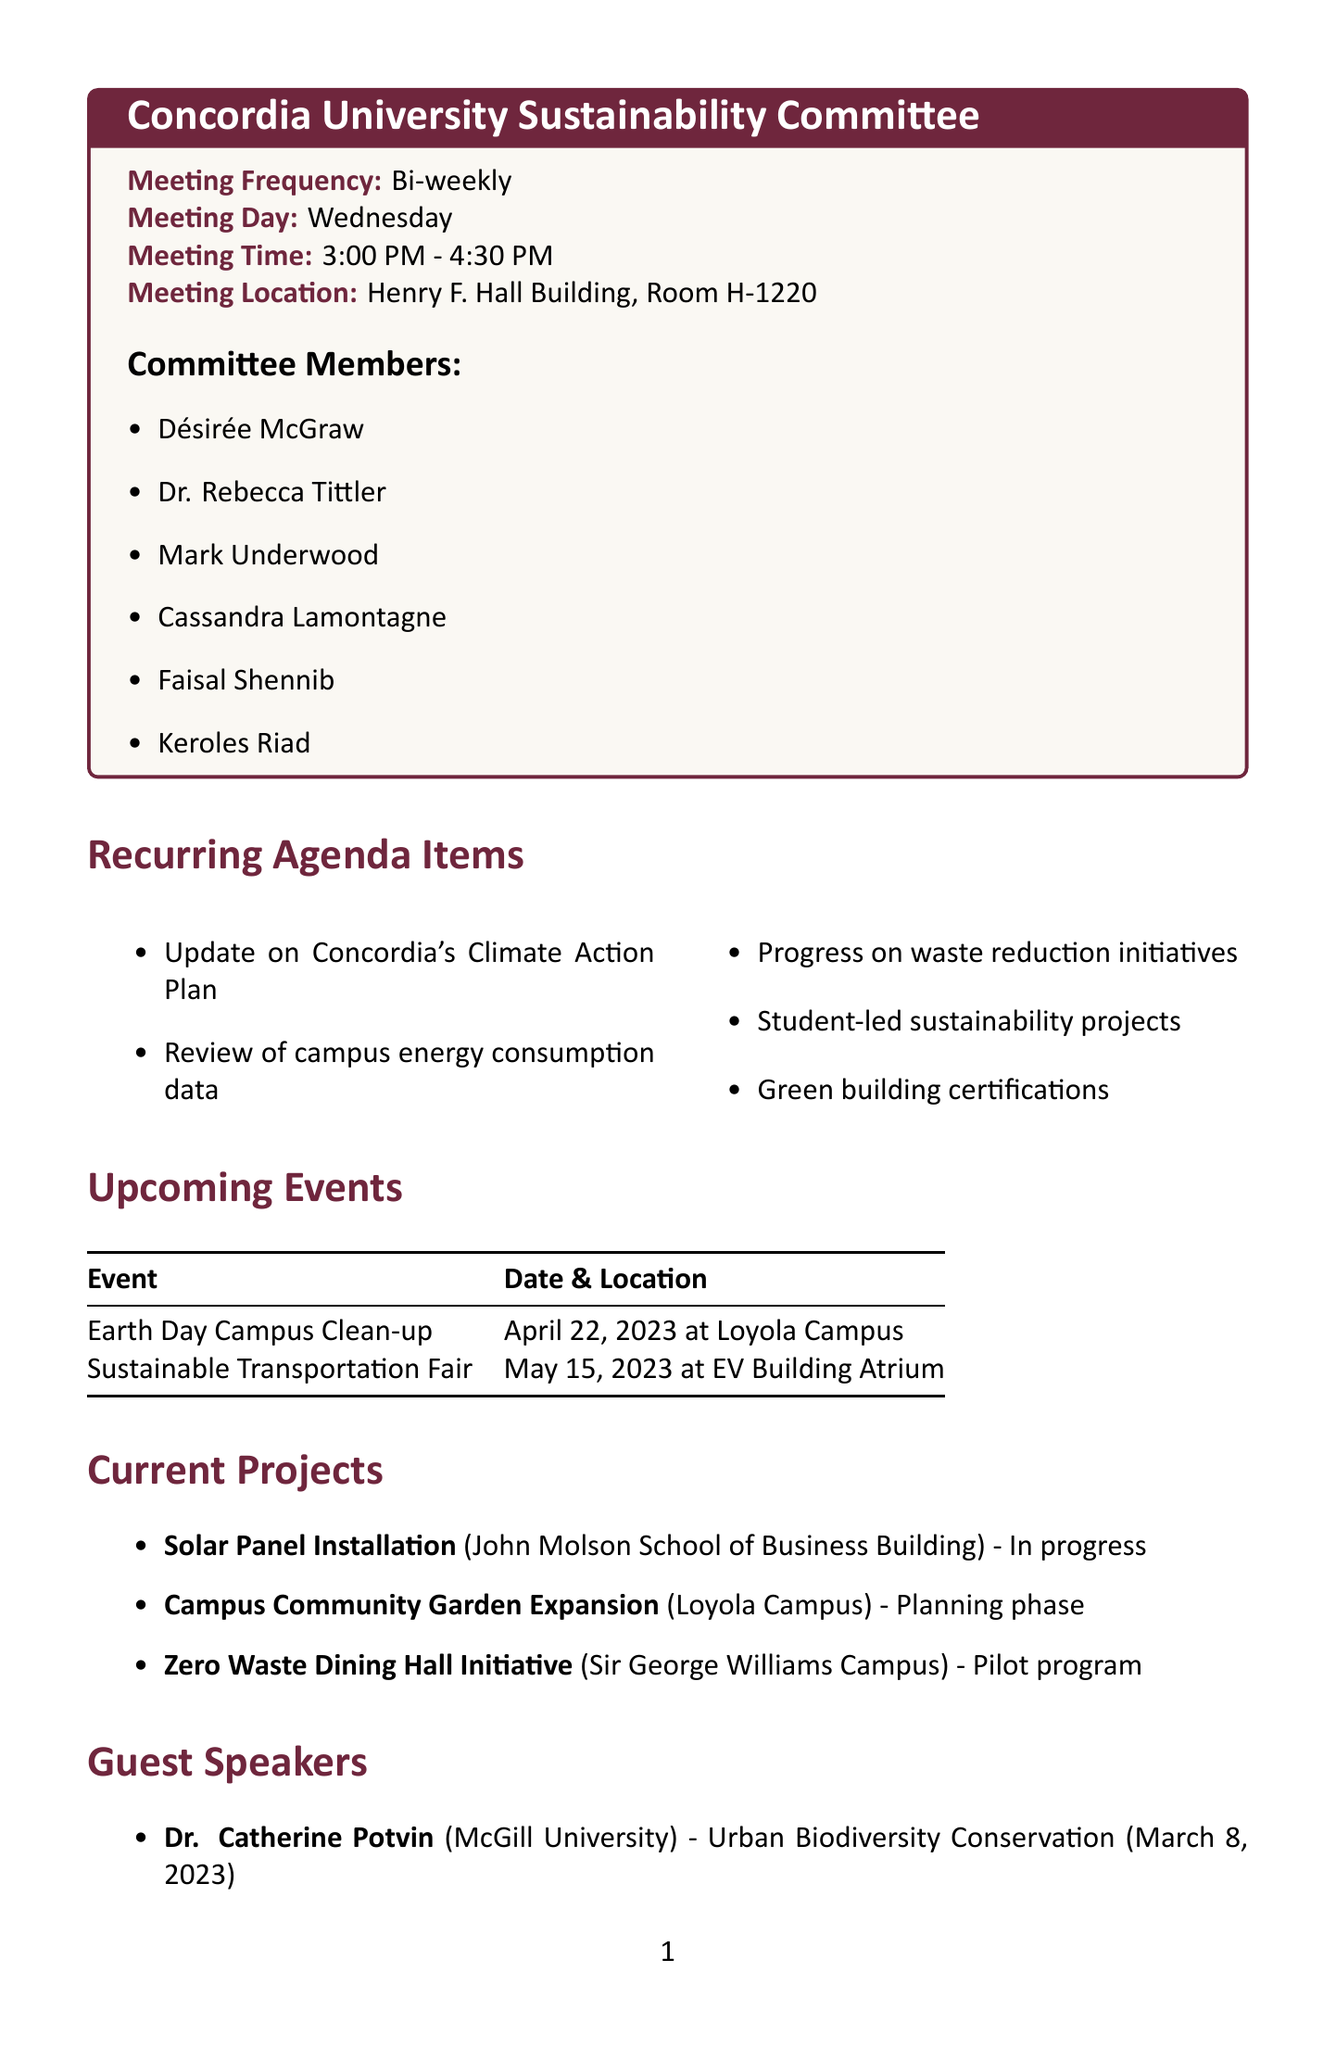What is the name of the committee? The name of the committee is stated as "Concordia University Sustainability Committee" in the document.
Answer: Concordia University Sustainability Committee When do the meetings occur? The document specifies that the meetings occur bi-weekly on Wednesdays.
Answer: Bi-weekly What time do the meetings start? The document mentions that meetings start at 3:00 PM.
Answer: 3:00 PM Who is the guest speaker on March 8, 2023? The document lists Dr. Catherine Potvin as the guest speaker on that date.
Answer: Dr. Catherine Potvin What is the status of the Solar Panel Installation project? The document indicates that the Solar Panel Installation project is currently in progress.
Answer: In progress How many subcommittees are there? The document lists five subcommittees under the committee.
Answer: 5 What is one action item mentioned in the document? The document includes various action items, and one example is submitting a quarterly sustainability report.
Answer: Submit quarterly sustainability report to the Board of Governors What is the location of the Sustainable Transportation Fair? The location of the Sustainable Transportation Fair is specified in the document as the EV Building Atrium.
Answer: EV Building Atrium Which member is listed first in the committee members? The first member listed in the document is Désirée McGraw.
Answer: Désirée McGraw 